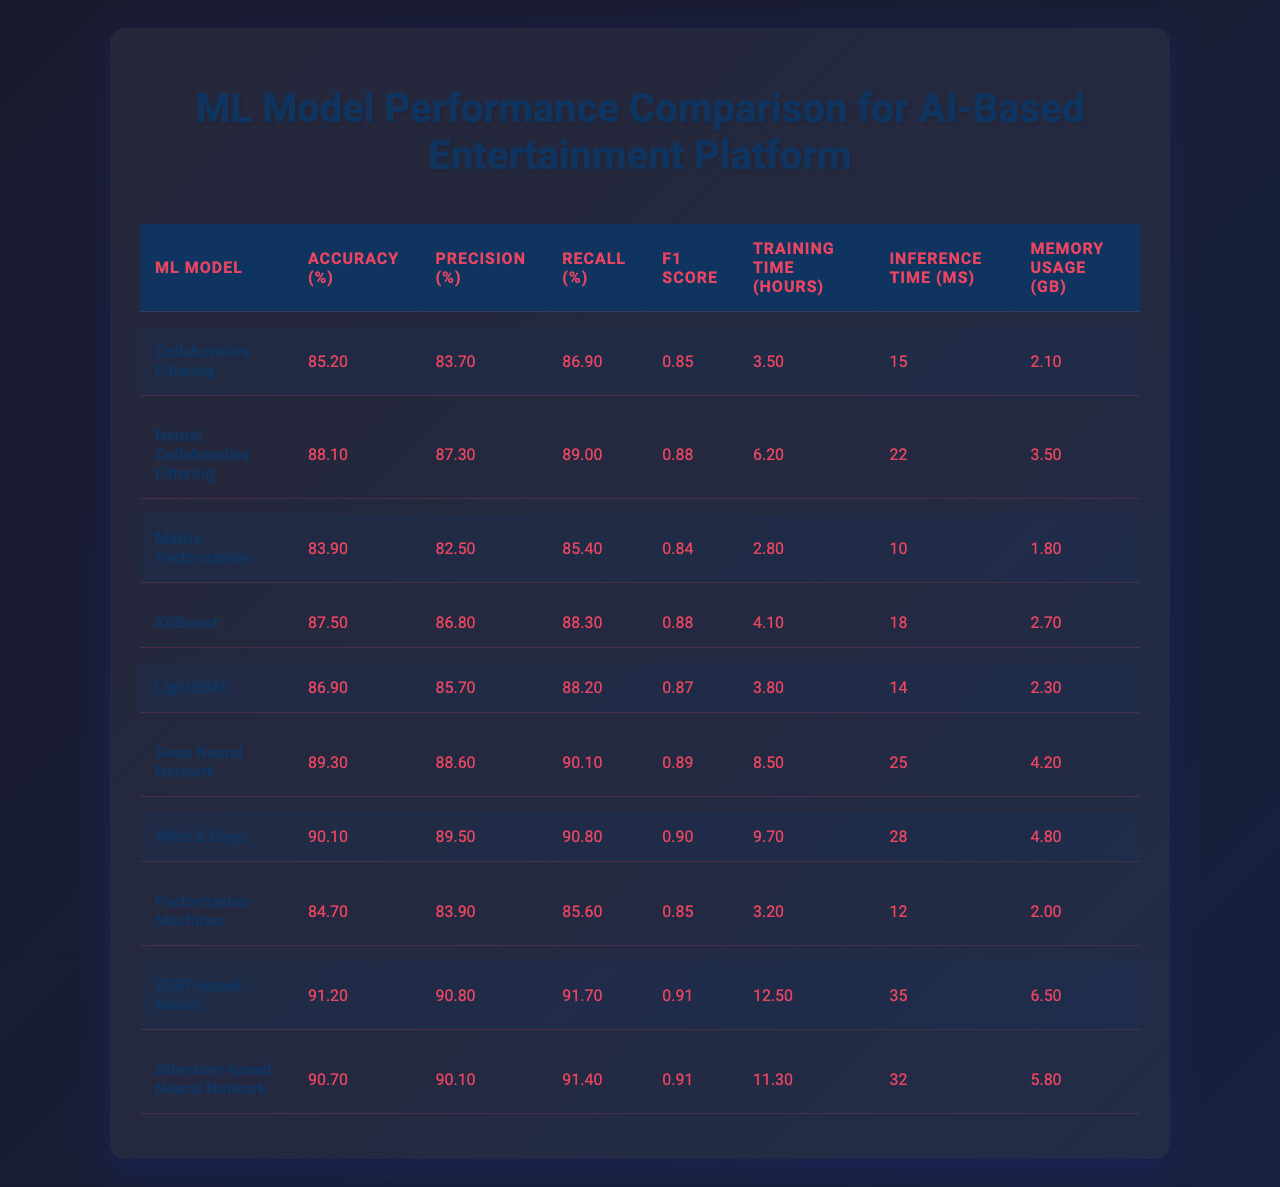What is the accuracy of the BERT-based Model? The accuracy of the BERT-based Model is listed directly in the table, which shows it to be 91.2%.
Answer: 91.2% Which model has the highest recall? The recall values for each model are listed, and the BERT-based Model has the highest recall at 91.7%.
Answer: BERT-based Model How long does the Deep Neural Network take to train? The training time for the Deep Neural Network is 8.5 hours, as indicated in the table.
Answer: 8.5 hours What is the average inference time of the models listed? The inference times are 15, 22, 10, 18, 14, 25, 28, 12, 35, and 32 ms. The sum is 15 + 22 + 10 + 18 + 14 + 25 + 28 + 12 + 35 + 32 =  286, and dividing by 10 gives an average of 28.6 ms.
Answer: 28.6 ms Is the XGBoost model faster than the LightGBM model in terms of inference time? The inference time for XGBoost is 18 ms while for LightGBM it is 14 ms, hence XGBoost is not faster than LightGBM.
Answer: No What is the memory usage of the Wide & Deep model? The memory usage for the Wide & Deep model is 4.8 GB, as shown in the table.
Answer: 4.8 GB Which model has the lowest accuracy, and what is that accuracy? Scanning through the accuracy values, Matrix Factorization has the lowest accuracy at 83.9%.
Answer: Matrix Factorization, 83.9% How much more training time does the BERT-based Model require compared to the Collaborative Filtering model? The training time for BERT-based Model is 12.5 hours, and for Collaborative Filtering, it is 3.5 hours. The difference is 12.5 - 3.5 = 9 hours more.
Answer: 9 hours Is the accuracy of Neural Collaborative Filtering higher than that of XGBoost? The accuracy of Neural Collaborative Filtering is 88.1%, while XGBoost's accuracy is 87.5%. Since 88.1 is greater than 87.5, the statement is true.
Answer: Yes If we consider the F1 scores, which two models have the closest F1 Score? The F1 scores are as follows: 0.853 (Collaborative Filtering), 0.881 (Neural Collaborative Filtering), 0.839 (Matrix Factorization), 0.875 (XGBoost), 0.869 (LightGBM), 0.893 (Deep Neural Network), 0.901 (Wide & Deep), 0.847 (Factorization Machines), 0.912 (BERT-based Model), and 0.907 (Attention-based Neural Network). The closest scores are between XGBoost and LightGBM, which have F1 scores of 0.875 and 0.869 respectively.
Answer: XGBoost and LightGBM What is the highest precision achieved among the models, and which model attained it? The precision values show that the BERT-based Model achieved the highest precision at 90.8%.
Answer: 90.8%, BERT-based Model 